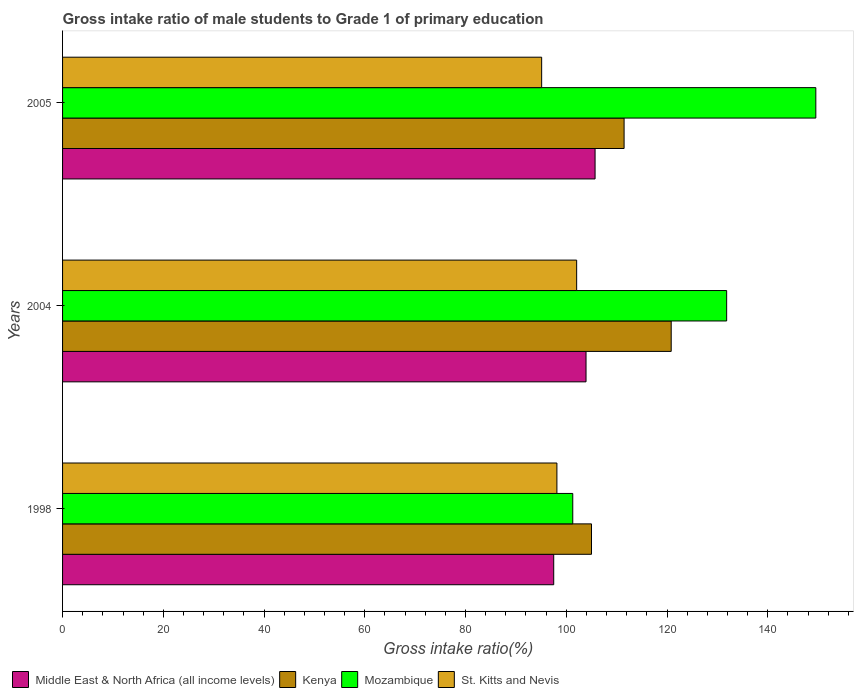How many groups of bars are there?
Ensure brevity in your answer.  3. Are the number of bars per tick equal to the number of legend labels?
Your answer should be compact. Yes. Are the number of bars on each tick of the Y-axis equal?
Your answer should be very brief. Yes. How many bars are there on the 3rd tick from the top?
Offer a very short reply. 4. How many bars are there on the 1st tick from the bottom?
Make the answer very short. 4. In how many cases, is the number of bars for a given year not equal to the number of legend labels?
Provide a short and direct response. 0. What is the gross intake ratio in Middle East & North Africa (all income levels) in 1998?
Give a very brief answer. 97.51. Across all years, what is the maximum gross intake ratio in Middle East & North Africa (all income levels)?
Your answer should be very brief. 105.72. Across all years, what is the minimum gross intake ratio in Kenya?
Your answer should be compact. 105.01. In which year was the gross intake ratio in Mozambique maximum?
Make the answer very short. 2005. What is the total gross intake ratio in Mozambique in the graph?
Your answer should be very brief. 382.67. What is the difference between the gross intake ratio in St. Kitts and Nevis in 2004 and that in 2005?
Offer a very short reply. 6.95. What is the difference between the gross intake ratio in Kenya in 2004 and the gross intake ratio in Mozambique in 1998?
Provide a succinct answer. 19.54. What is the average gross intake ratio in Kenya per year?
Offer a terse response. 112.44. In the year 2005, what is the difference between the gross intake ratio in Middle East & North Africa (all income levels) and gross intake ratio in Mozambique?
Your response must be concise. -43.83. What is the ratio of the gross intake ratio in St. Kitts and Nevis in 1998 to that in 2005?
Give a very brief answer. 1.03. Is the difference between the gross intake ratio in Middle East & North Africa (all income levels) in 1998 and 2004 greater than the difference between the gross intake ratio in Mozambique in 1998 and 2004?
Your answer should be very brief. Yes. What is the difference between the highest and the second highest gross intake ratio in Kenya?
Keep it short and to the point. 9.35. What is the difference between the highest and the lowest gross intake ratio in Mozambique?
Give a very brief answer. 48.25. Is it the case that in every year, the sum of the gross intake ratio in Mozambique and gross intake ratio in Middle East & North Africa (all income levels) is greater than the sum of gross intake ratio in Kenya and gross intake ratio in St. Kitts and Nevis?
Give a very brief answer. No. What does the 2nd bar from the top in 1998 represents?
Give a very brief answer. Mozambique. What does the 4th bar from the bottom in 1998 represents?
Offer a very short reply. St. Kitts and Nevis. Is it the case that in every year, the sum of the gross intake ratio in Mozambique and gross intake ratio in Middle East & North Africa (all income levels) is greater than the gross intake ratio in St. Kitts and Nevis?
Provide a succinct answer. Yes. How many bars are there?
Make the answer very short. 12. Are all the bars in the graph horizontal?
Keep it short and to the point. Yes. What is the difference between two consecutive major ticks on the X-axis?
Provide a succinct answer. 20. Are the values on the major ticks of X-axis written in scientific E-notation?
Your answer should be compact. No. Does the graph contain any zero values?
Your response must be concise. No. Where does the legend appear in the graph?
Provide a short and direct response. Bottom left. How many legend labels are there?
Offer a terse response. 4. What is the title of the graph?
Provide a short and direct response. Gross intake ratio of male students to Grade 1 of primary education. What is the label or title of the X-axis?
Offer a very short reply. Gross intake ratio(%). What is the Gross intake ratio(%) of Middle East & North Africa (all income levels) in 1998?
Give a very brief answer. 97.51. What is the Gross intake ratio(%) of Kenya in 1998?
Make the answer very short. 105.01. What is the Gross intake ratio(%) in Mozambique in 1998?
Provide a short and direct response. 101.29. What is the Gross intake ratio(%) of St. Kitts and Nevis in 1998?
Offer a very short reply. 98.14. What is the Gross intake ratio(%) of Middle East & North Africa (all income levels) in 2004?
Give a very brief answer. 103.92. What is the Gross intake ratio(%) of Kenya in 2004?
Offer a very short reply. 120.83. What is the Gross intake ratio(%) of Mozambique in 2004?
Ensure brevity in your answer.  131.84. What is the Gross intake ratio(%) in St. Kitts and Nevis in 2004?
Offer a terse response. 102.06. What is the Gross intake ratio(%) of Middle East & North Africa (all income levels) in 2005?
Your answer should be very brief. 105.72. What is the Gross intake ratio(%) of Kenya in 2005?
Offer a very short reply. 111.48. What is the Gross intake ratio(%) in Mozambique in 2005?
Provide a short and direct response. 149.54. What is the Gross intake ratio(%) of St. Kitts and Nevis in 2005?
Your answer should be very brief. 95.11. Across all years, what is the maximum Gross intake ratio(%) of Middle East & North Africa (all income levels)?
Offer a very short reply. 105.72. Across all years, what is the maximum Gross intake ratio(%) in Kenya?
Offer a very short reply. 120.83. Across all years, what is the maximum Gross intake ratio(%) of Mozambique?
Make the answer very short. 149.54. Across all years, what is the maximum Gross intake ratio(%) in St. Kitts and Nevis?
Your answer should be compact. 102.06. Across all years, what is the minimum Gross intake ratio(%) in Middle East & North Africa (all income levels)?
Your answer should be very brief. 97.51. Across all years, what is the minimum Gross intake ratio(%) of Kenya?
Offer a terse response. 105.01. Across all years, what is the minimum Gross intake ratio(%) of Mozambique?
Provide a succinct answer. 101.29. Across all years, what is the minimum Gross intake ratio(%) of St. Kitts and Nevis?
Your answer should be compact. 95.11. What is the total Gross intake ratio(%) in Middle East & North Africa (all income levels) in the graph?
Provide a short and direct response. 307.14. What is the total Gross intake ratio(%) of Kenya in the graph?
Offer a terse response. 337.32. What is the total Gross intake ratio(%) in Mozambique in the graph?
Offer a terse response. 382.67. What is the total Gross intake ratio(%) in St. Kitts and Nevis in the graph?
Your answer should be very brief. 295.31. What is the difference between the Gross intake ratio(%) of Middle East & North Africa (all income levels) in 1998 and that in 2004?
Offer a terse response. -6.42. What is the difference between the Gross intake ratio(%) in Kenya in 1998 and that in 2004?
Your answer should be very brief. -15.82. What is the difference between the Gross intake ratio(%) in Mozambique in 1998 and that in 2004?
Give a very brief answer. -30.55. What is the difference between the Gross intake ratio(%) in St. Kitts and Nevis in 1998 and that in 2004?
Your answer should be compact. -3.92. What is the difference between the Gross intake ratio(%) of Middle East & North Africa (all income levels) in 1998 and that in 2005?
Make the answer very short. -8.21. What is the difference between the Gross intake ratio(%) in Kenya in 1998 and that in 2005?
Keep it short and to the point. -6.47. What is the difference between the Gross intake ratio(%) of Mozambique in 1998 and that in 2005?
Make the answer very short. -48.25. What is the difference between the Gross intake ratio(%) of St. Kitts and Nevis in 1998 and that in 2005?
Provide a short and direct response. 3.03. What is the difference between the Gross intake ratio(%) in Middle East & North Africa (all income levels) in 2004 and that in 2005?
Provide a short and direct response. -1.79. What is the difference between the Gross intake ratio(%) in Kenya in 2004 and that in 2005?
Offer a terse response. 9.35. What is the difference between the Gross intake ratio(%) in Mozambique in 2004 and that in 2005?
Offer a terse response. -17.7. What is the difference between the Gross intake ratio(%) of St. Kitts and Nevis in 2004 and that in 2005?
Provide a short and direct response. 6.95. What is the difference between the Gross intake ratio(%) in Middle East & North Africa (all income levels) in 1998 and the Gross intake ratio(%) in Kenya in 2004?
Make the answer very short. -23.33. What is the difference between the Gross intake ratio(%) of Middle East & North Africa (all income levels) in 1998 and the Gross intake ratio(%) of Mozambique in 2004?
Offer a very short reply. -34.33. What is the difference between the Gross intake ratio(%) of Middle East & North Africa (all income levels) in 1998 and the Gross intake ratio(%) of St. Kitts and Nevis in 2004?
Make the answer very short. -4.56. What is the difference between the Gross intake ratio(%) of Kenya in 1998 and the Gross intake ratio(%) of Mozambique in 2004?
Provide a succinct answer. -26.83. What is the difference between the Gross intake ratio(%) of Kenya in 1998 and the Gross intake ratio(%) of St. Kitts and Nevis in 2004?
Keep it short and to the point. 2.95. What is the difference between the Gross intake ratio(%) of Mozambique in 1998 and the Gross intake ratio(%) of St. Kitts and Nevis in 2004?
Make the answer very short. -0.77. What is the difference between the Gross intake ratio(%) of Middle East & North Africa (all income levels) in 1998 and the Gross intake ratio(%) of Kenya in 2005?
Keep it short and to the point. -13.97. What is the difference between the Gross intake ratio(%) of Middle East & North Africa (all income levels) in 1998 and the Gross intake ratio(%) of Mozambique in 2005?
Ensure brevity in your answer.  -52.04. What is the difference between the Gross intake ratio(%) of Middle East & North Africa (all income levels) in 1998 and the Gross intake ratio(%) of St. Kitts and Nevis in 2005?
Your answer should be very brief. 2.39. What is the difference between the Gross intake ratio(%) in Kenya in 1998 and the Gross intake ratio(%) in Mozambique in 2005?
Offer a very short reply. -44.54. What is the difference between the Gross intake ratio(%) in Kenya in 1998 and the Gross intake ratio(%) in St. Kitts and Nevis in 2005?
Your answer should be compact. 9.9. What is the difference between the Gross intake ratio(%) in Mozambique in 1998 and the Gross intake ratio(%) in St. Kitts and Nevis in 2005?
Give a very brief answer. 6.18. What is the difference between the Gross intake ratio(%) of Middle East & North Africa (all income levels) in 2004 and the Gross intake ratio(%) of Kenya in 2005?
Your response must be concise. -7.56. What is the difference between the Gross intake ratio(%) in Middle East & North Africa (all income levels) in 2004 and the Gross intake ratio(%) in Mozambique in 2005?
Ensure brevity in your answer.  -45.62. What is the difference between the Gross intake ratio(%) of Middle East & North Africa (all income levels) in 2004 and the Gross intake ratio(%) of St. Kitts and Nevis in 2005?
Provide a succinct answer. 8.81. What is the difference between the Gross intake ratio(%) of Kenya in 2004 and the Gross intake ratio(%) of Mozambique in 2005?
Ensure brevity in your answer.  -28.71. What is the difference between the Gross intake ratio(%) in Kenya in 2004 and the Gross intake ratio(%) in St. Kitts and Nevis in 2005?
Make the answer very short. 25.72. What is the difference between the Gross intake ratio(%) of Mozambique in 2004 and the Gross intake ratio(%) of St. Kitts and Nevis in 2005?
Keep it short and to the point. 36.73. What is the average Gross intake ratio(%) of Middle East & North Africa (all income levels) per year?
Provide a short and direct response. 102.38. What is the average Gross intake ratio(%) in Kenya per year?
Give a very brief answer. 112.44. What is the average Gross intake ratio(%) of Mozambique per year?
Provide a succinct answer. 127.56. What is the average Gross intake ratio(%) of St. Kitts and Nevis per year?
Offer a terse response. 98.44. In the year 1998, what is the difference between the Gross intake ratio(%) of Middle East & North Africa (all income levels) and Gross intake ratio(%) of Kenya?
Offer a terse response. -7.5. In the year 1998, what is the difference between the Gross intake ratio(%) in Middle East & North Africa (all income levels) and Gross intake ratio(%) in Mozambique?
Ensure brevity in your answer.  -3.78. In the year 1998, what is the difference between the Gross intake ratio(%) of Middle East & North Africa (all income levels) and Gross intake ratio(%) of St. Kitts and Nevis?
Provide a short and direct response. -0.64. In the year 1998, what is the difference between the Gross intake ratio(%) of Kenya and Gross intake ratio(%) of Mozambique?
Give a very brief answer. 3.72. In the year 1998, what is the difference between the Gross intake ratio(%) of Kenya and Gross intake ratio(%) of St. Kitts and Nevis?
Offer a very short reply. 6.87. In the year 1998, what is the difference between the Gross intake ratio(%) of Mozambique and Gross intake ratio(%) of St. Kitts and Nevis?
Offer a terse response. 3.15. In the year 2004, what is the difference between the Gross intake ratio(%) of Middle East & North Africa (all income levels) and Gross intake ratio(%) of Kenya?
Provide a succinct answer. -16.91. In the year 2004, what is the difference between the Gross intake ratio(%) in Middle East & North Africa (all income levels) and Gross intake ratio(%) in Mozambique?
Provide a short and direct response. -27.92. In the year 2004, what is the difference between the Gross intake ratio(%) in Middle East & North Africa (all income levels) and Gross intake ratio(%) in St. Kitts and Nevis?
Offer a terse response. 1.86. In the year 2004, what is the difference between the Gross intake ratio(%) of Kenya and Gross intake ratio(%) of Mozambique?
Offer a terse response. -11.01. In the year 2004, what is the difference between the Gross intake ratio(%) of Kenya and Gross intake ratio(%) of St. Kitts and Nevis?
Give a very brief answer. 18.77. In the year 2004, what is the difference between the Gross intake ratio(%) in Mozambique and Gross intake ratio(%) in St. Kitts and Nevis?
Give a very brief answer. 29.78. In the year 2005, what is the difference between the Gross intake ratio(%) of Middle East & North Africa (all income levels) and Gross intake ratio(%) of Kenya?
Offer a very short reply. -5.76. In the year 2005, what is the difference between the Gross intake ratio(%) of Middle East & North Africa (all income levels) and Gross intake ratio(%) of Mozambique?
Your answer should be very brief. -43.83. In the year 2005, what is the difference between the Gross intake ratio(%) of Middle East & North Africa (all income levels) and Gross intake ratio(%) of St. Kitts and Nevis?
Your response must be concise. 10.61. In the year 2005, what is the difference between the Gross intake ratio(%) in Kenya and Gross intake ratio(%) in Mozambique?
Keep it short and to the point. -38.06. In the year 2005, what is the difference between the Gross intake ratio(%) of Kenya and Gross intake ratio(%) of St. Kitts and Nevis?
Keep it short and to the point. 16.37. In the year 2005, what is the difference between the Gross intake ratio(%) of Mozambique and Gross intake ratio(%) of St. Kitts and Nevis?
Offer a terse response. 54.43. What is the ratio of the Gross intake ratio(%) in Middle East & North Africa (all income levels) in 1998 to that in 2004?
Ensure brevity in your answer.  0.94. What is the ratio of the Gross intake ratio(%) of Kenya in 1998 to that in 2004?
Ensure brevity in your answer.  0.87. What is the ratio of the Gross intake ratio(%) of Mozambique in 1998 to that in 2004?
Provide a short and direct response. 0.77. What is the ratio of the Gross intake ratio(%) of St. Kitts and Nevis in 1998 to that in 2004?
Offer a terse response. 0.96. What is the ratio of the Gross intake ratio(%) in Middle East & North Africa (all income levels) in 1998 to that in 2005?
Ensure brevity in your answer.  0.92. What is the ratio of the Gross intake ratio(%) in Kenya in 1998 to that in 2005?
Offer a very short reply. 0.94. What is the ratio of the Gross intake ratio(%) in Mozambique in 1998 to that in 2005?
Offer a terse response. 0.68. What is the ratio of the Gross intake ratio(%) in St. Kitts and Nevis in 1998 to that in 2005?
Provide a succinct answer. 1.03. What is the ratio of the Gross intake ratio(%) of Kenya in 2004 to that in 2005?
Your answer should be compact. 1.08. What is the ratio of the Gross intake ratio(%) of Mozambique in 2004 to that in 2005?
Make the answer very short. 0.88. What is the ratio of the Gross intake ratio(%) in St. Kitts and Nevis in 2004 to that in 2005?
Provide a succinct answer. 1.07. What is the difference between the highest and the second highest Gross intake ratio(%) of Middle East & North Africa (all income levels)?
Provide a short and direct response. 1.79. What is the difference between the highest and the second highest Gross intake ratio(%) of Kenya?
Give a very brief answer. 9.35. What is the difference between the highest and the second highest Gross intake ratio(%) in Mozambique?
Your answer should be compact. 17.7. What is the difference between the highest and the second highest Gross intake ratio(%) in St. Kitts and Nevis?
Provide a succinct answer. 3.92. What is the difference between the highest and the lowest Gross intake ratio(%) of Middle East & North Africa (all income levels)?
Provide a succinct answer. 8.21. What is the difference between the highest and the lowest Gross intake ratio(%) of Kenya?
Your answer should be very brief. 15.82. What is the difference between the highest and the lowest Gross intake ratio(%) of Mozambique?
Ensure brevity in your answer.  48.25. What is the difference between the highest and the lowest Gross intake ratio(%) of St. Kitts and Nevis?
Offer a terse response. 6.95. 